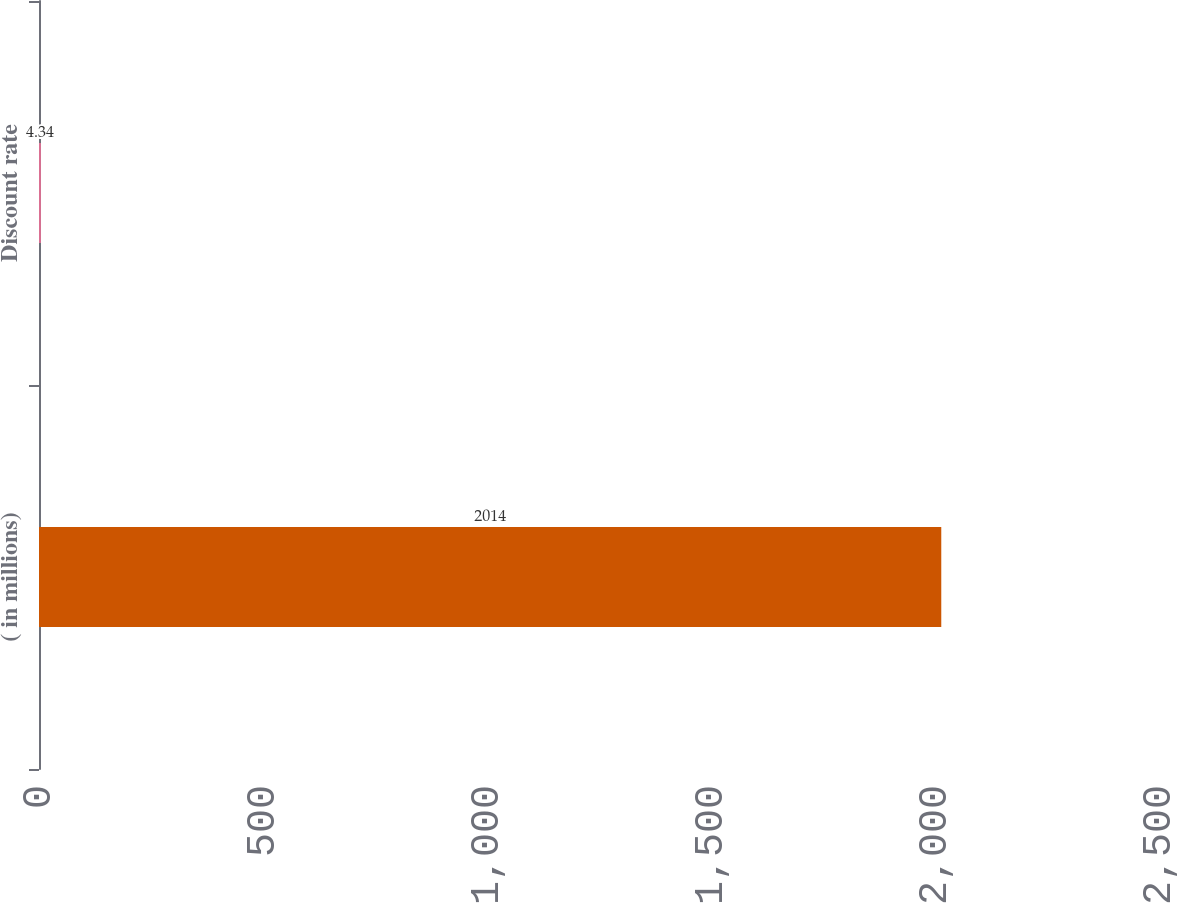Convert chart to OTSL. <chart><loc_0><loc_0><loc_500><loc_500><bar_chart><fcel>( in millions)<fcel>Discount rate<nl><fcel>2014<fcel>4.34<nl></chart> 